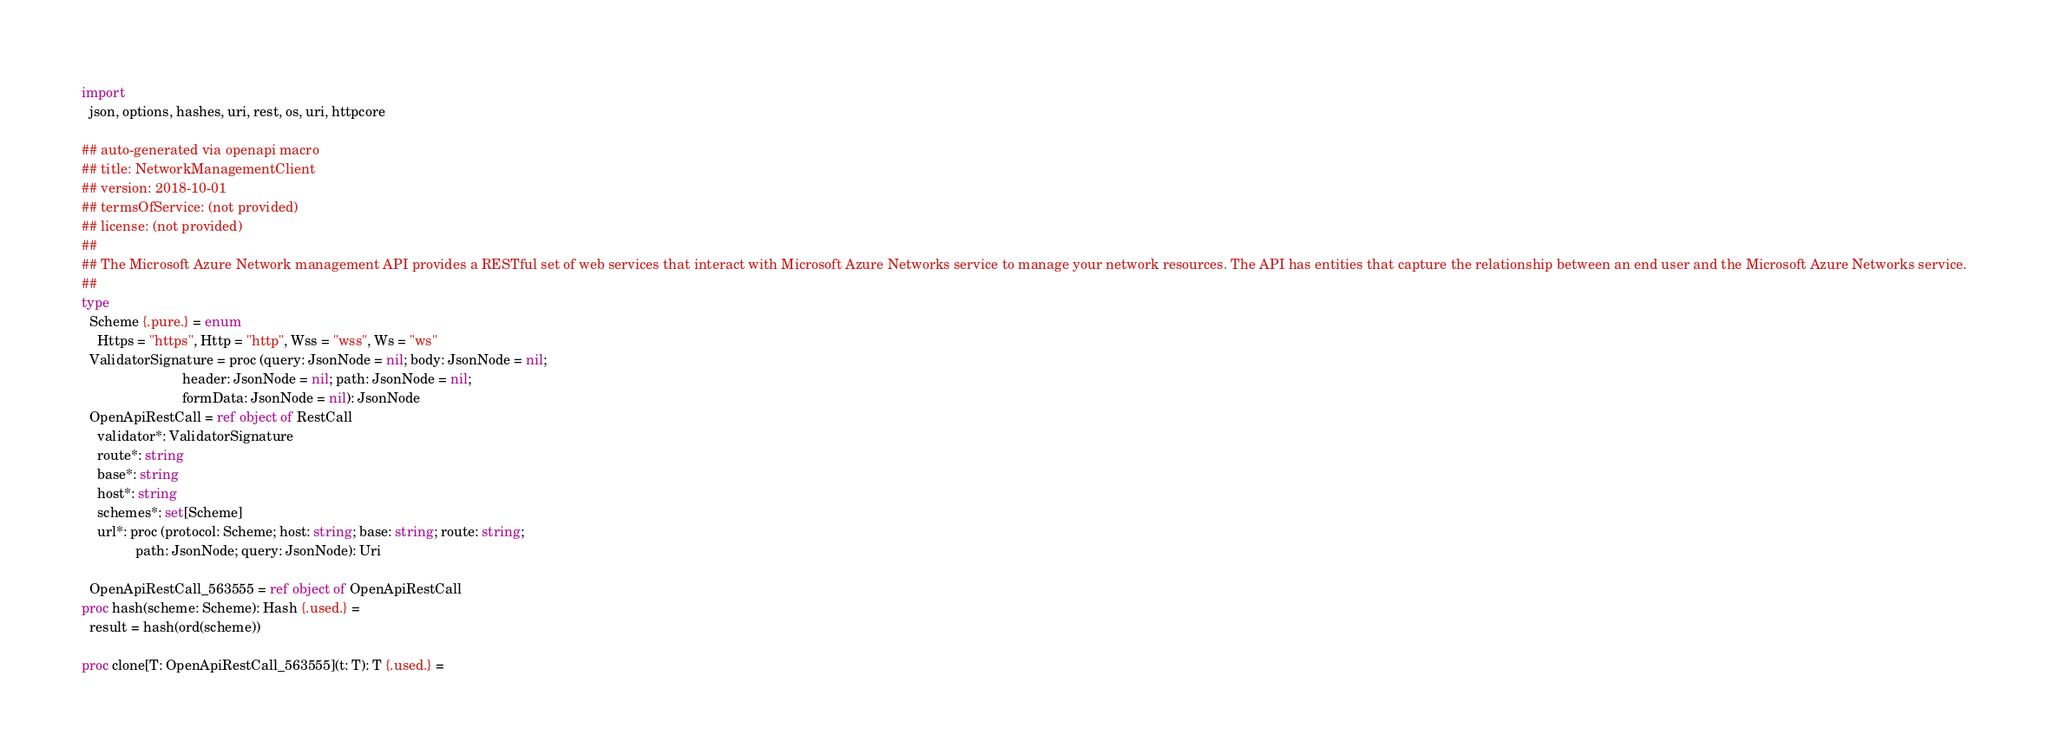Convert code to text. <code><loc_0><loc_0><loc_500><loc_500><_Nim_>
import
  json, options, hashes, uri, rest, os, uri, httpcore

## auto-generated via openapi macro
## title: NetworkManagementClient
## version: 2018-10-01
## termsOfService: (not provided)
## license: (not provided)
## 
## The Microsoft Azure Network management API provides a RESTful set of web services that interact with Microsoft Azure Networks service to manage your network resources. The API has entities that capture the relationship between an end user and the Microsoft Azure Networks service.
## 
type
  Scheme {.pure.} = enum
    Https = "https", Http = "http", Wss = "wss", Ws = "ws"
  ValidatorSignature = proc (query: JsonNode = nil; body: JsonNode = nil;
                          header: JsonNode = nil; path: JsonNode = nil;
                          formData: JsonNode = nil): JsonNode
  OpenApiRestCall = ref object of RestCall
    validator*: ValidatorSignature
    route*: string
    base*: string
    host*: string
    schemes*: set[Scheme]
    url*: proc (protocol: Scheme; host: string; base: string; route: string;
              path: JsonNode; query: JsonNode): Uri

  OpenApiRestCall_563555 = ref object of OpenApiRestCall
proc hash(scheme: Scheme): Hash {.used.} =
  result = hash(ord(scheme))

proc clone[T: OpenApiRestCall_563555](t: T): T {.used.} =</code> 